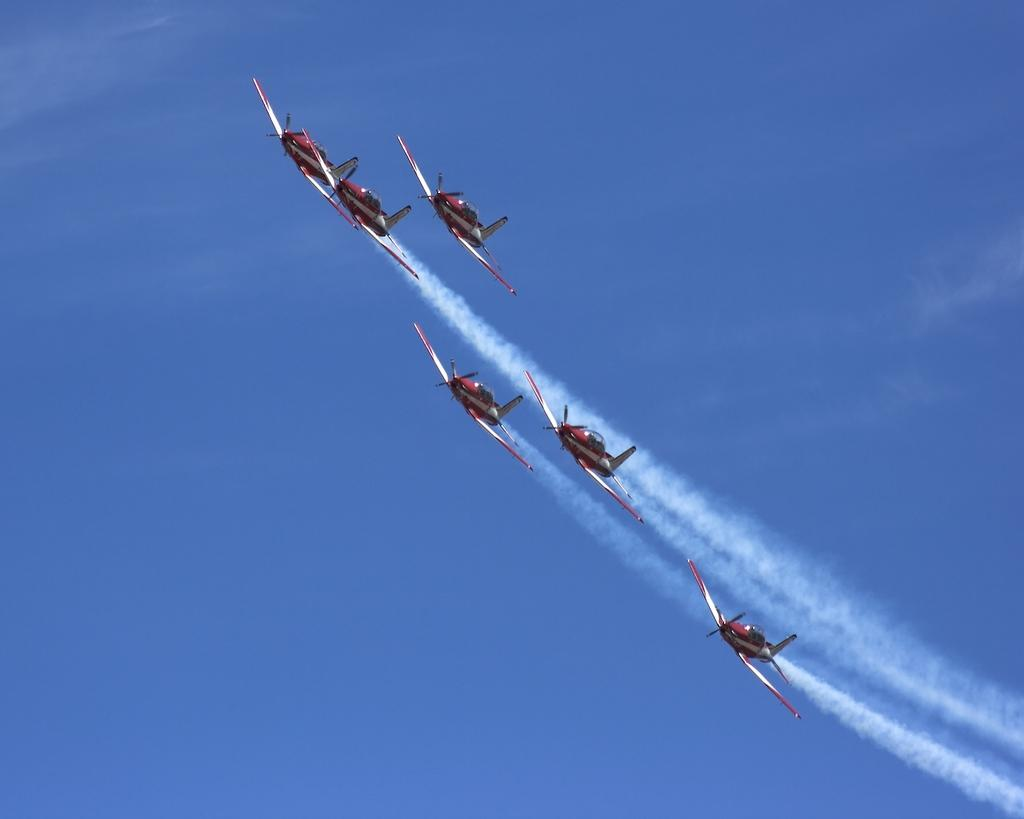What is the main subject of the image? The main subject of the image is aircrafts. Where are the aircrafts located in the image? The aircrafts are in the air. What can be seen in the background of the image? There is smoke and the sky visible in the background of the image. Can you determine the time of day the image was taken? The image was likely taken during the day, as the sky is visible. What type of bubble can be seen in the image? There is no bubble present in the image. Is there a team of people playing a game in the image? There is no team or game visible in the image; it features aircrafts in the air. 